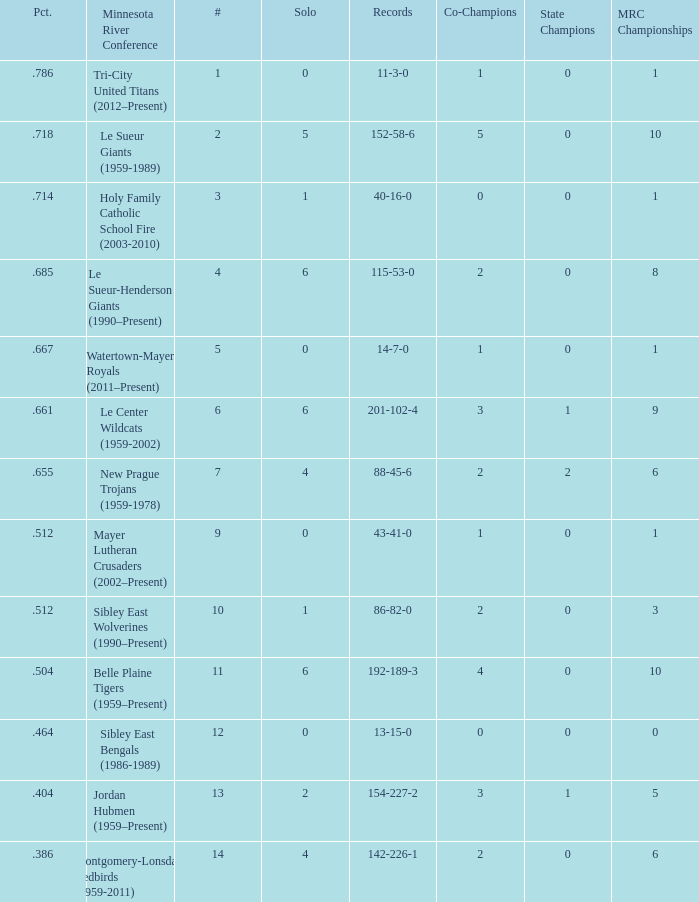What's the total number of teams placed at #2 on the list? 1.0. 